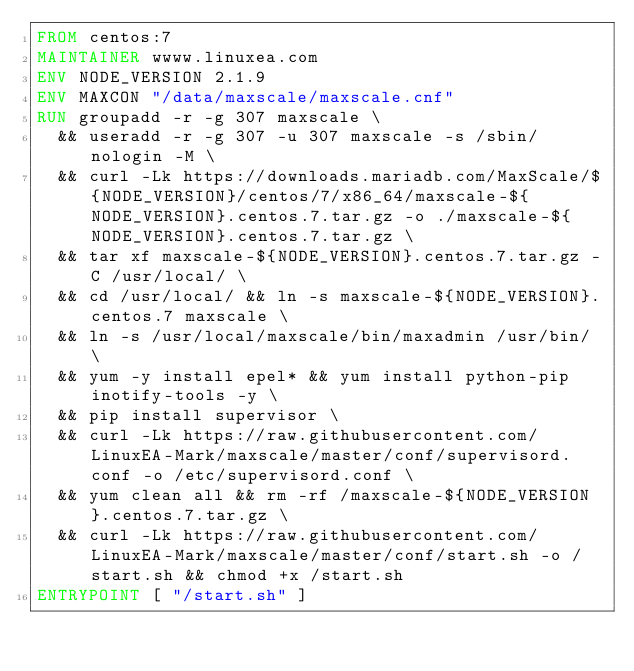Convert code to text. <code><loc_0><loc_0><loc_500><loc_500><_Dockerfile_>FROM centos:7
MAINTAINER wwww.linuxea.com
ENV NODE_VERSION 2.1.9
ENV MAXCON "/data/maxscale/maxscale.cnf"
RUN groupadd -r -g 307 maxscale \
	&& useradd -r -g 307 -u 307 maxscale -s /sbin/nologin -M \
	&& curl -Lk https://downloads.mariadb.com/MaxScale/${NODE_VERSION}/centos/7/x86_64/maxscale-${NODE_VERSION}.centos.7.tar.gz -o ./maxscale-${NODE_VERSION}.centos.7.tar.gz \
	&& tar xf maxscale-${NODE_VERSION}.centos.7.tar.gz -C /usr/local/ \
	&& cd /usr/local/ && ln -s maxscale-${NODE_VERSION}.centos.7 maxscale \
	&& ln -s /usr/local/maxscale/bin/maxadmin /usr/bin/ \
	&& yum -y install epel* && yum install python-pip inotify-tools -y \
	&& pip install supervisor \
	&& curl -Lk https://raw.githubusercontent.com/LinuxEA-Mark/maxscale/master/conf/supervisord.conf -o /etc/supervisord.conf \
	&& yum clean all && rm -rf /maxscale-${NODE_VERSION}.centos.7.tar.gz \
  && curl -Lk https://raw.githubusercontent.com/LinuxEA-Mark/maxscale/master/conf/start.sh -o /start.sh && chmod +x /start.sh
ENTRYPOINT [ "/start.sh" ]
</code> 